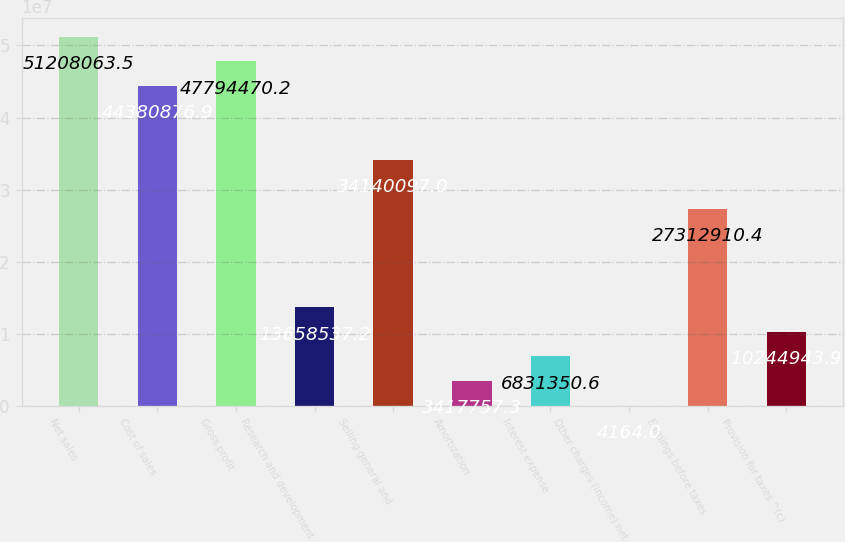Convert chart to OTSL. <chart><loc_0><loc_0><loc_500><loc_500><bar_chart><fcel>Net sales<fcel>Cost of sales<fcel>Gross profit<fcel>Research and development<fcel>Selling general and<fcel>Amortization<fcel>Interest expense<fcel>Other charges (income) net<fcel>Earnings before taxes<fcel>Provision for taxes ^(c)<nl><fcel>5.12081e+07<fcel>4.43809e+07<fcel>4.77945e+07<fcel>1.36585e+07<fcel>3.41401e+07<fcel>3.41776e+06<fcel>6.83135e+06<fcel>4164<fcel>2.73129e+07<fcel>1.02449e+07<nl></chart> 